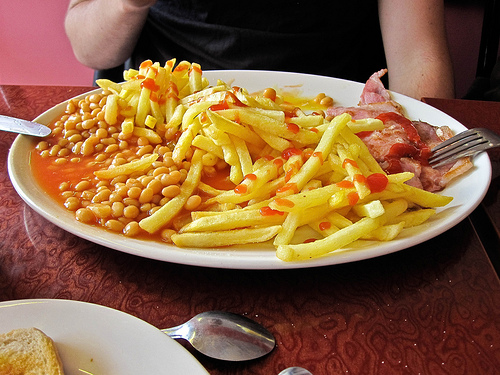<image>
Can you confirm if the beans is on the fries? Yes. Looking at the image, I can see the beans is positioned on top of the fries, with the fries providing support. Is there a ketchup on the french fry? No. The ketchup is not positioned on the french fry. They may be near each other, but the ketchup is not supported by or resting on top of the french fry. 